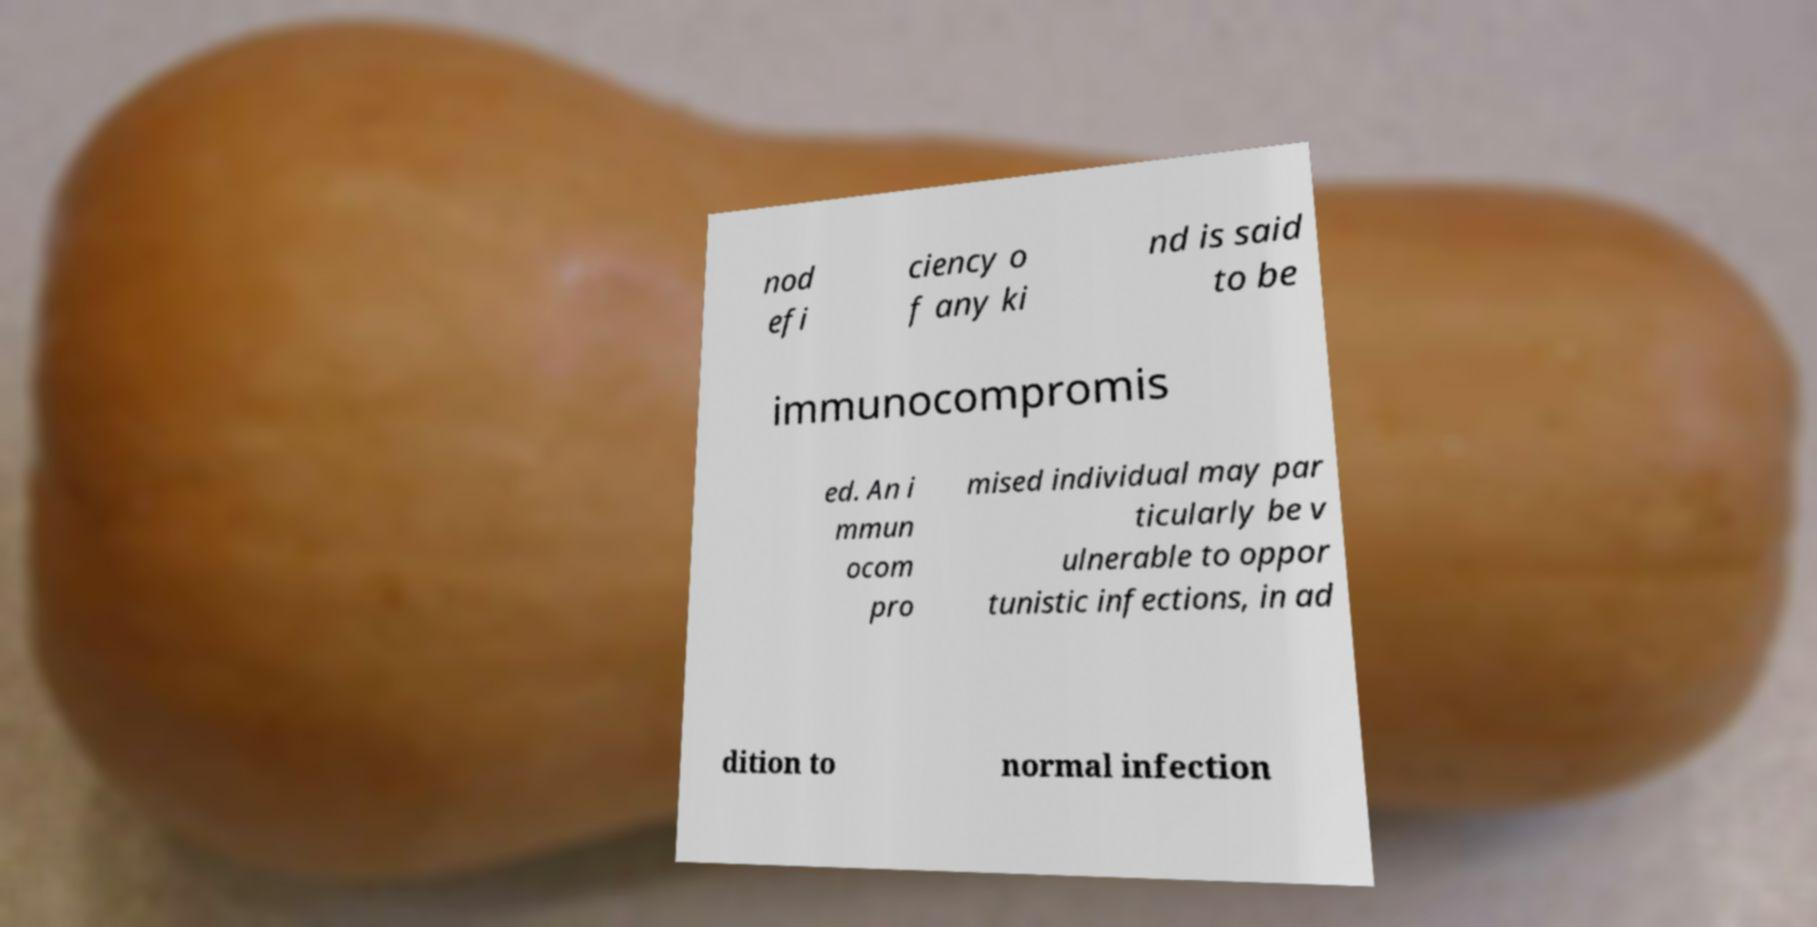Could you extract and type out the text from this image? nod efi ciency o f any ki nd is said to be immunocompromis ed. An i mmun ocom pro mised individual may par ticularly be v ulnerable to oppor tunistic infections, in ad dition to normal infection 